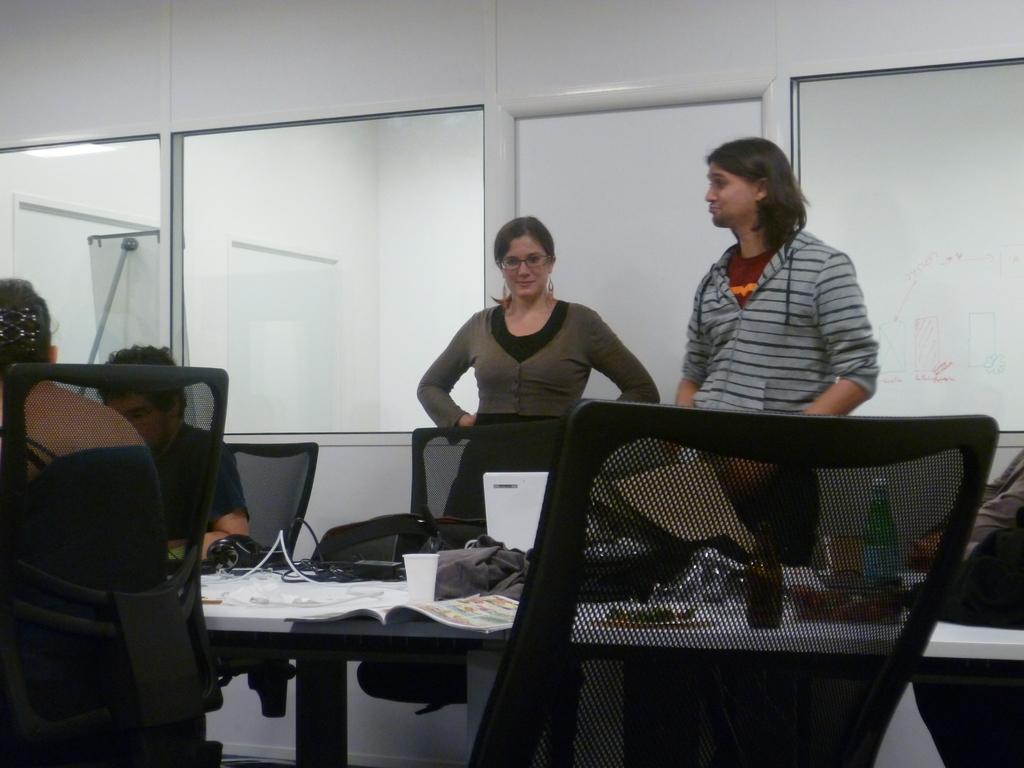How many people are in the image? There are multiple people in the image. What are the positions of the people in the image? Two of the people are standing, and the rest of the people are sitting. What objects can be seen on the table in the image? There are bottles and books on the table. What color is the orange that the passenger is holding in the image? There is no orange or passenger present in the image. 